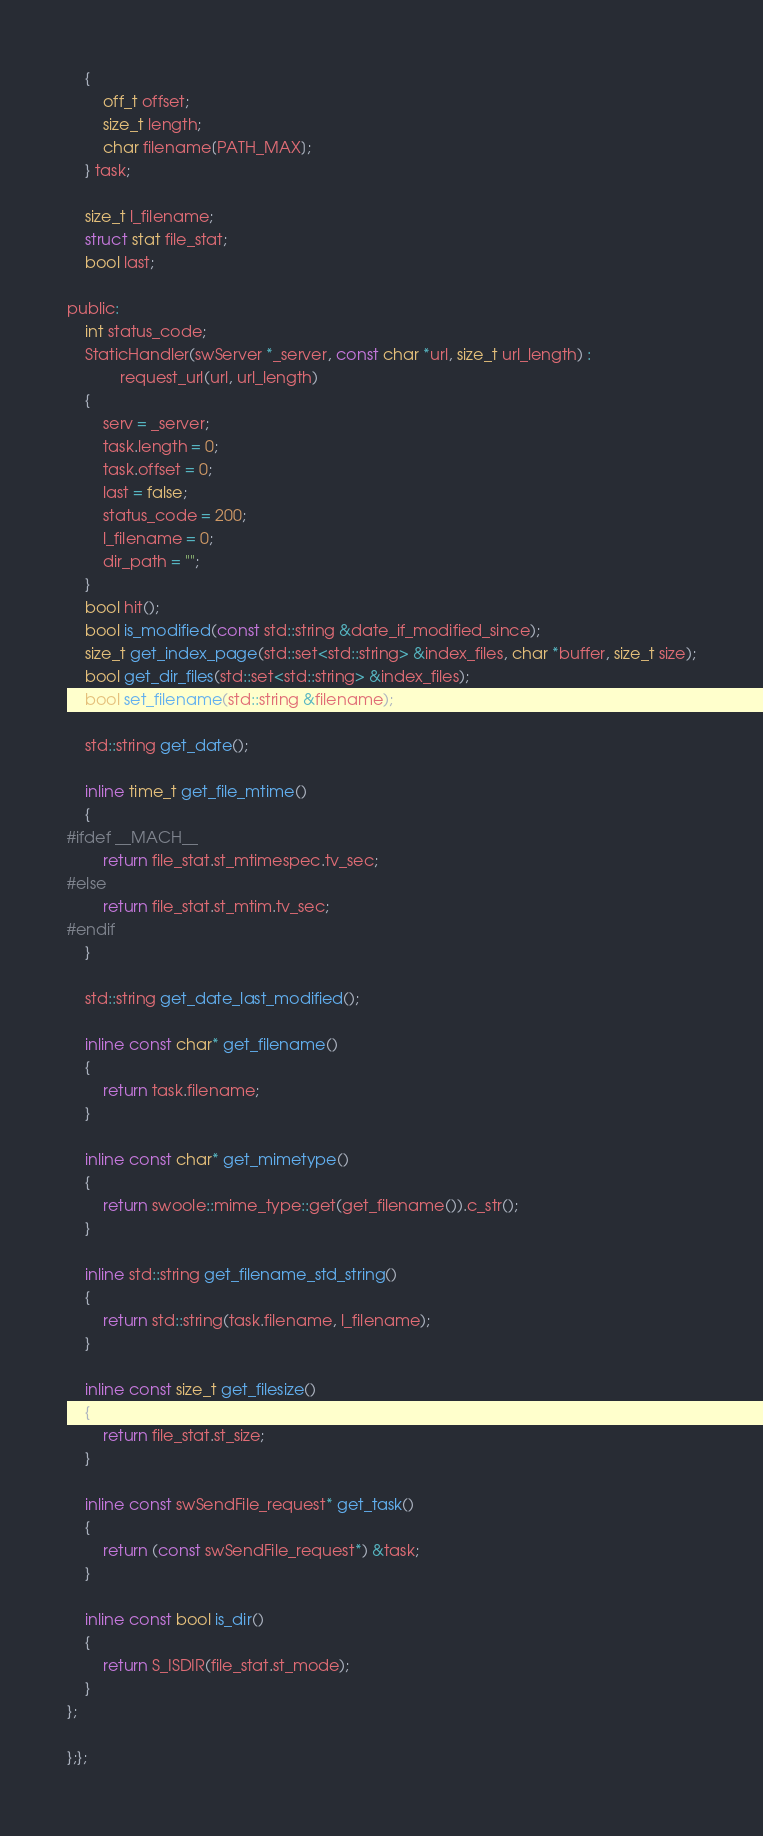Convert code to text. <code><loc_0><loc_0><loc_500><loc_500><_C_>    {
        off_t offset;
        size_t length;
        char filename[PATH_MAX];
    } task;

    size_t l_filename;
    struct stat file_stat;
    bool last;

public:
    int status_code;
    StaticHandler(swServer *_server, const char *url, size_t url_length) :
            request_url(url, url_length)
    {
        serv = _server;
        task.length = 0;
        task.offset = 0;
        last = false;
        status_code = 200;
        l_filename = 0;
        dir_path = "";
    }
    bool hit();
    bool is_modified(const std::string &date_if_modified_since);
    size_t get_index_page(std::set<std::string> &index_files, char *buffer, size_t size);
    bool get_dir_files(std::set<std::string> &index_files);
    bool set_filename(std::string &filename);

    std::string get_date();

    inline time_t get_file_mtime()
    {
#ifdef __MACH__
        return file_stat.st_mtimespec.tv_sec;
#else
        return file_stat.st_mtim.tv_sec;
#endif
    }

    std::string get_date_last_modified();

    inline const char* get_filename()
    {
        return task.filename;
    }

    inline const char* get_mimetype()
    {
        return swoole::mime_type::get(get_filename()).c_str();
    }

    inline std::string get_filename_std_string()
    {
        return std::string(task.filename, l_filename);
    }

    inline const size_t get_filesize()
    {
        return file_stat.st_size;
    }

    inline const swSendFile_request* get_task()
    {
        return (const swSendFile_request*) &task;
    }

    inline const bool is_dir()
    {
        return S_ISDIR(file_stat.st_mode);
    }
};

};};
</code> 